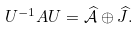<formula> <loc_0><loc_0><loc_500><loc_500>U ^ { - 1 } A U = \widehat { \mathcal { A } } \oplus \widehat { J } .</formula> 